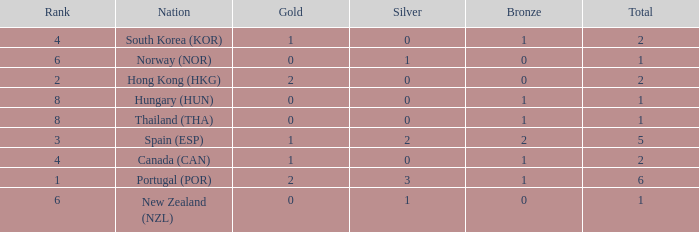What is the lowest Total containing a Bronze of 0 and Rank smaller than 2? None. 